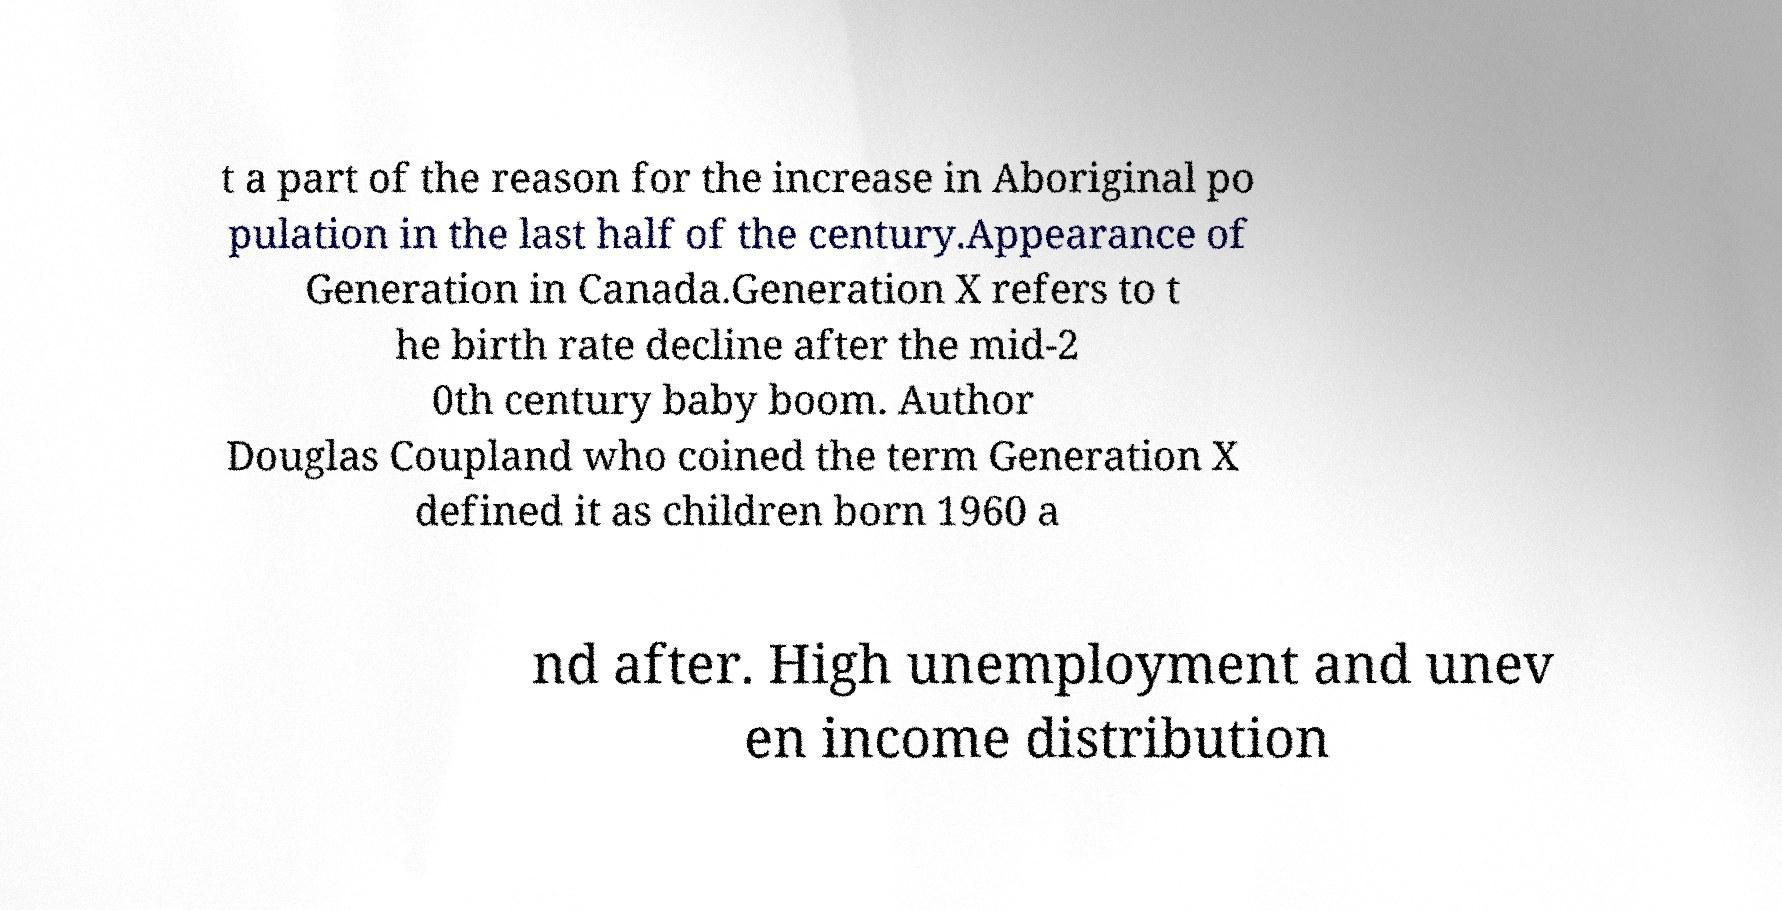Could you extract and type out the text from this image? t a part of the reason for the increase in Aboriginal po pulation in the last half of the century.Appearance of Generation in Canada.Generation X refers to t he birth rate decline after the mid-2 0th century baby boom. Author Douglas Coupland who coined the term Generation X defined it as children born 1960 a nd after. High unemployment and unev en income distribution 